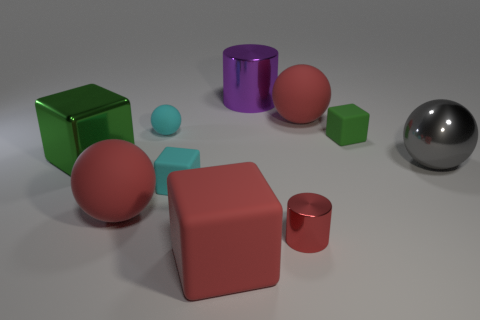Subtract 1 balls. How many balls are left? 3 Subtract all blue blocks. Subtract all purple balls. How many blocks are left? 4 Subtract all cylinders. How many objects are left? 8 Add 5 red blocks. How many red blocks are left? 6 Add 1 tiny blue balls. How many tiny blue balls exist? 1 Subtract 1 red balls. How many objects are left? 9 Subtract all cyan metal cylinders. Subtract all big purple things. How many objects are left? 9 